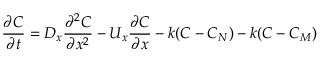<formula> <loc_0><loc_0><loc_500><loc_500>{ \frac { \partial C } { \partial t } } = D _ { x } { \frac { \partial ^ { 2 } C } { \partial x ^ { 2 } } } - U _ { x } { \frac { \partial C } { \partial x } } - k ( C - C _ { N } ) - k ( C - C _ { M } )</formula> 